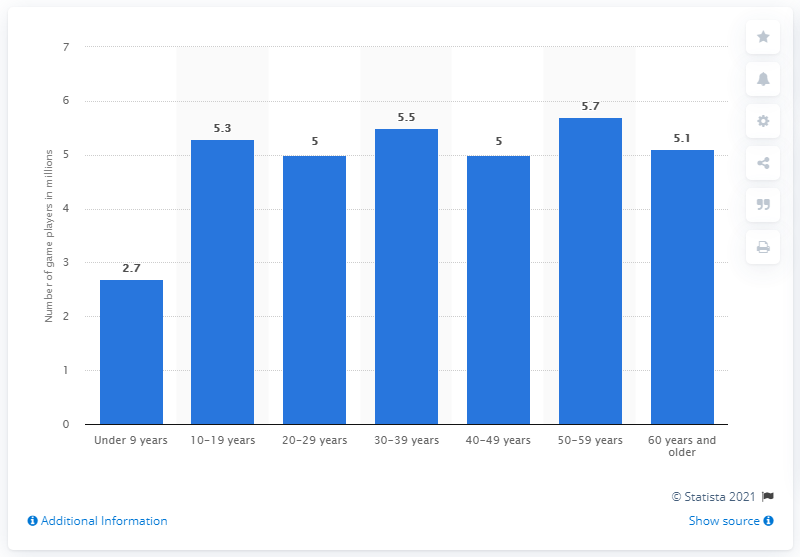Identify some key points in this picture. In 2020, it is estimated that 5.3 million people between the ages of 10 and 19 in Germany played video games. 